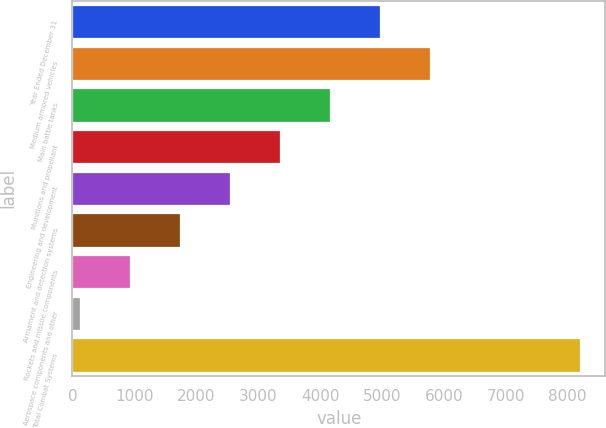Convert chart. <chart><loc_0><loc_0><loc_500><loc_500><bar_chart><fcel>Year Ended December 31<fcel>Medium armored vehicles<fcel>Main battle tanks<fcel>Munitions and propellant<fcel>Engineering and development<fcel>Armament and detection systems<fcel>Rockets and missile components<fcel>Aerospace components and other<fcel>Total Combat Systems<nl><fcel>4968<fcel>5774.5<fcel>4161.5<fcel>3355<fcel>2548.5<fcel>1742<fcel>935.5<fcel>129<fcel>8194<nl></chart> 